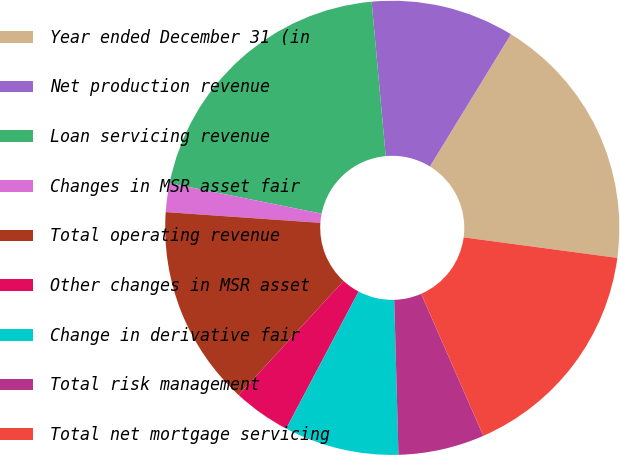Convert chart. <chart><loc_0><loc_0><loc_500><loc_500><pie_chart><fcel>Year ended December 31 (in<fcel>Net production revenue<fcel>Loan servicing revenue<fcel>Changes in MSR asset fair<fcel>Total operating revenue<fcel>Other changes in MSR asset<fcel>Change in derivative fair<fcel>Total risk management<fcel>Total net mortgage servicing<nl><fcel>18.36%<fcel>10.2%<fcel>20.4%<fcel>2.05%<fcel>14.28%<fcel>4.09%<fcel>8.17%<fcel>6.13%<fcel>16.32%<nl></chart> 